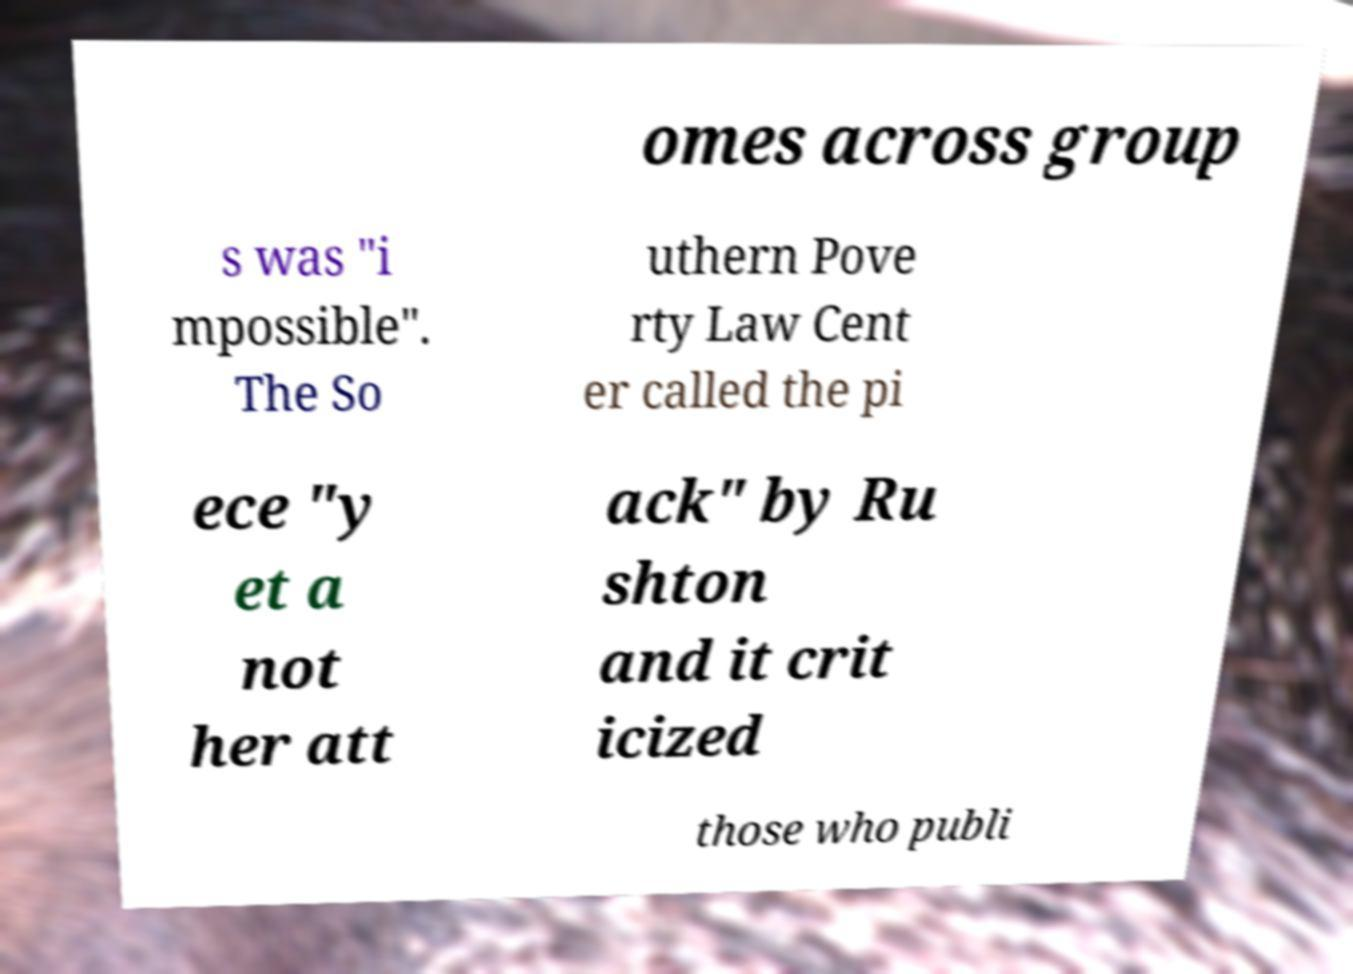Could you extract and type out the text from this image? omes across group s was "i mpossible". The So uthern Pove rty Law Cent er called the pi ece "y et a not her att ack" by Ru shton and it crit icized those who publi 